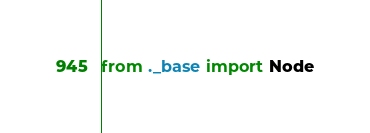<code> <loc_0><loc_0><loc_500><loc_500><_Python_>from ._base import Node
</code> 